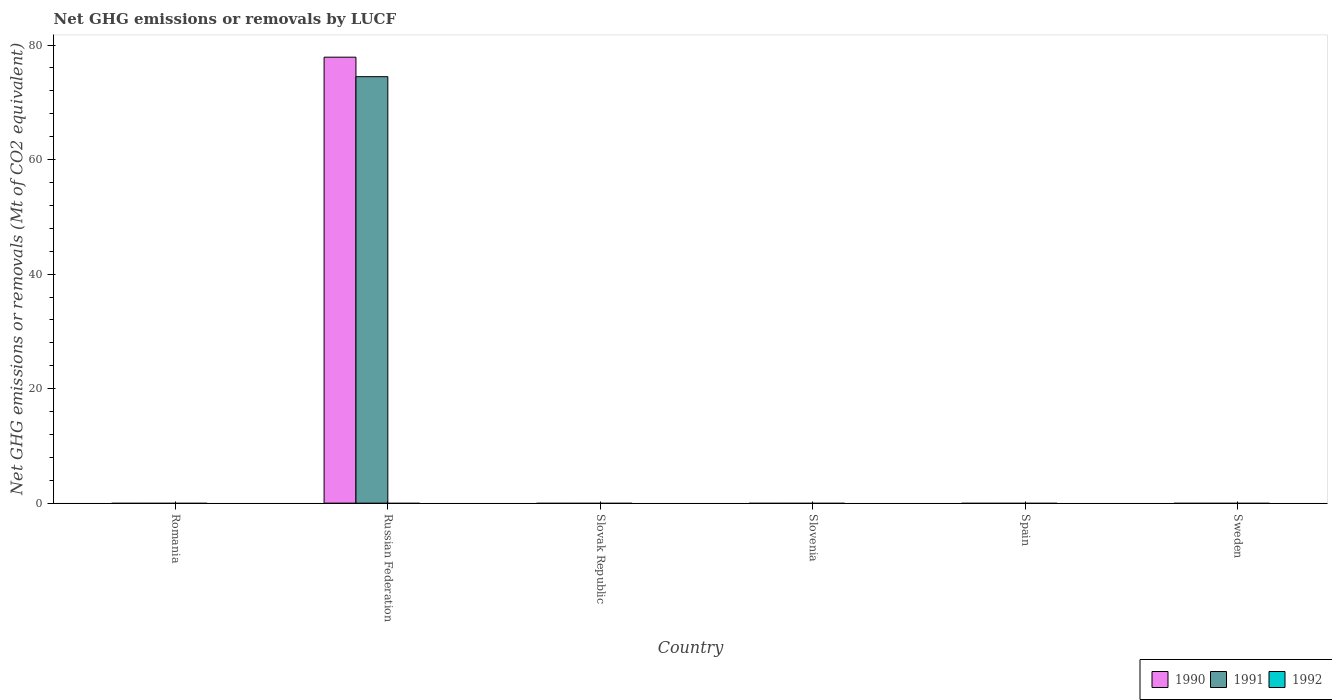How many different coloured bars are there?
Provide a short and direct response. 2. Are the number of bars per tick equal to the number of legend labels?
Provide a succinct answer. No. How many bars are there on the 6th tick from the left?
Provide a short and direct response. 0. How many bars are there on the 3rd tick from the right?
Ensure brevity in your answer.  0. What is the label of the 1st group of bars from the left?
Your answer should be compact. Romania. Across all countries, what is the maximum net GHG emissions or removals by LUCF in 1991?
Your answer should be very brief. 74.48. Across all countries, what is the minimum net GHG emissions or removals by LUCF in 1992?
Ensure brevity in your answer.  0. In which country was the net GHG emissions or removals by LUCF in 1990 maximum?
Keep it short and to the point. Russian Federation. What is the total net GHG emissions or removals by LUCF in 1992 in the graph?
Keep it short and to the point. 0. What is the difference between the net GHG emissions or removals by LUCF in 1992 in Romania and the net GHG emissions or removals by LUCF in 1990 in Slovenia?
Offer a very short reply. 0. What is the difference between the net GHG emissions or removals by LUCF of/in 1991 and net GHG emissions or removals by LUCF of/in 1990 in Russian Federation?
Offer a very short reply. -3.41. In how many countries, is the net GHG emissions or removals by LUCF in 1991 greater than 52 Mt?
Your response must be concise. 1. What is the difference between the highest and the lowest net GHG emissions or removals by LUCF in 1990?
Ensure brevity in your answer.  77.88. In how many countries, is the net GHG emissions or removals by LUCF in 1992 greater than the average net GHG emissions or removals by LUCF in 1992 taken over all countries?
Your response must be concise. 0. How many bars are there?
Provide a succinct answer. 2. What is the difference between two consecutive major ticks on the Y-axis?
Ensure brevity in your answer.  20. Does the graph contain grids?
Your response must be concise. No. Where does the legend appear in the graph?
Provide a succinct answer. Bottom right. What is the title of the graph?
Provide a short and direct response. Net GHG emissions or removals by LUCF. Does "1970" appear as one of the legend labels in the graph?
Your answer should be very brief. No. What is the label or title of the Y-axis?
Offer a terse response. Net GHG emissions or removals (Mt of CO2 equivalent). What is the Net GHG emissions or removals (Mt of CO2 equivalent) in 1990 in Romania?
Your answer should be very brief. 0. What is the Net GHG emissions or removals (Mt of CO2 equivalent) of 1992 in Romania?
Your response must be concise. 0. What is the Net GHG emissions or removals (Mt of CO2 equivalent) of 1990 in Russian Federation?
Your answer should be very brief. 77.88. What is the Net GHG emissions or removals (Mt of CO2 equivalent) of 1991 in Russian Federation?
Ensure brevity in your answer.  74.48. What is the Net GHG emissions or removals (Mt of CO2 equivalent) of 1992 in Russian Federation?
Your answer should be compact. 0. What is the Net GHG emissions or removals (Mt of CO2 equivalent) of 1991 in Slovak Republic?
Provide a succinct answer. 0. What is the Net GHG emissions or removals (Mt of CO2 equivalent) in 1990 in Slovenia?
Provide a short and direct response. 0. What is the Net GHG emissions or removals (Mt of CO2 equivalent) in 1991 in Slovenia?
Provide a short and direct response. 0. What is the Net GHG emissions or removals (Mt of CO2 equivalent) in 1991 in Spain?
Offer a very short reply. 0. What is the Net GHG emissions or removals (Mt of CO2 equivalent) in 1992 in Spain?
Offer a very short reply. 0. What is the Net GHG emissions or removals (Mt of CO2 equivalent) of 1991 in Sweden?
Provide a short and direct response. 0. Across all countries, what is the maximum Net GHG emissions or removals (Mt of CO2 equivalent) of 1990?
Give a very brief answer. 77.88. Across all countries, what is the maximum Net GHG emissions or removals (Mt of CO2 equivalent) in 1991?
Your answer should be compact. 74.48. Across all countries, what is the minimum Net GHG emissions or removals (Mt of CO2 equivalent) in 1990?
Your answer should be compact. 0. Across all countries, what is the minimum Net GHG emissions or removals (Mt of CO2 equivalent) of 1991?
Your answer should be compact. 0. What is the total Net GHG emissions or removals (Mt of CO2 equivalent) of 1990 in the graph?
Ensure brevity in your answer.  77.89. What is the total Net GHG emissions or removals (Mt of CO2 equivalent) of 1991 in the graph?
Ensure brevity in your answer.  74.48. What is the total Net GHG emissions or removals (Mt of CO2 equivalent) of 1992 in the graph?
Provide a succinct answer. 0. What is the average Net GHG emissions or removals (Mt of CO2 equivalent) in 1990 per country?
Make the answer very short. 12.98. What is the average Net GHG emissions or removals (Mt of CO2 equivalent) of 1991 per country?
Provide a short and direct response. 12.41. What is the average Net GHG emissions or removals (Mt of CO2 equivalent) of 1992 per country?
Offer a terse response. 0. What is the difference between the Net GHG emissions or removals (Mt of CO2 equivalent) in 1990 and Net GHG emissions or removals (Mt of CO2 equivalent) in 1991 in Russian Federation?
Give a very brief answer. 3.41. What is the difference between the highest and the lowest Net GHG emissions or removals (Mt of CO2 equivalent) in 1990?
Provide a succinct answer. 77.89. What is the difference between the highest and the lowest Net GHG emissions or removals (Mt of CO2 equivalent) in 1991?
Keep it short and to the point. 74.48. 